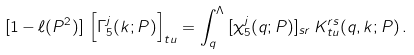Convert formula to latex. <formula><loc_0><loc_0><loc_500><loc_500>[ 1 - \ell ( P ^ { 2 } ) ] \, \left [ \Gamma _ { 5 } ^ { j } ( k ; P ) \right ] _ { t u } = \int ^ { \Lambda } _ { q } \, [ \chi _ { 5 } ^ { j } ( q ; P ) ] _ { s r } \, K ^ { r s } _ { t u } ( q , k ; P ) \, .</formula> 